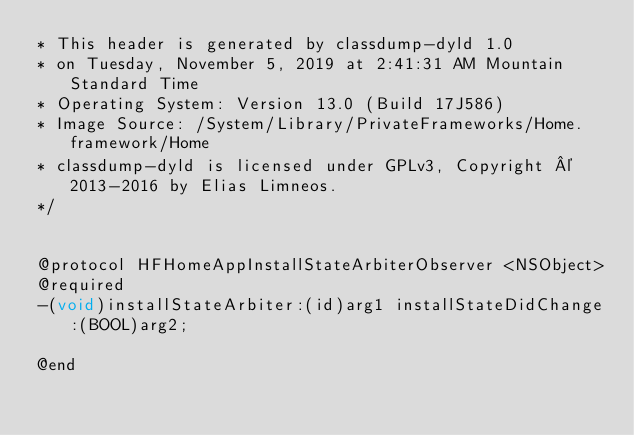Convert code to text. <code><loc_0><loc_0><loc_500><loc_500><_C_>* This header is generated by classdump-dyld 1.0
* on Tuesday, November 5, 2019 at 2:41:31 AM Mountain Standard Time
* Operating System: Version 13.0 (Build 17J586)
* Image Source: /System/Library/PrivateFrameworks/Home.framework/Home
* classdump-dyld is licensed under GPLv3, Copyright © 2013-2016 by Elias Limneos.
*/


@protocol HFHomeAppInstallStateArbiterObserver <NSObject>
@required
-(void)installStateArbiter:(id)arg1 installStateDidChange:(BOOL)arg2;

@end

</code> 